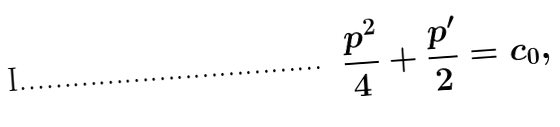<formula> <loc_0><loc_0><loc_500><loc_500>\frac { p ^ { 2 } } { 4 } + \frac { p ^ { \prime } } { 2 } = c _ { 0 } ,</formula> 